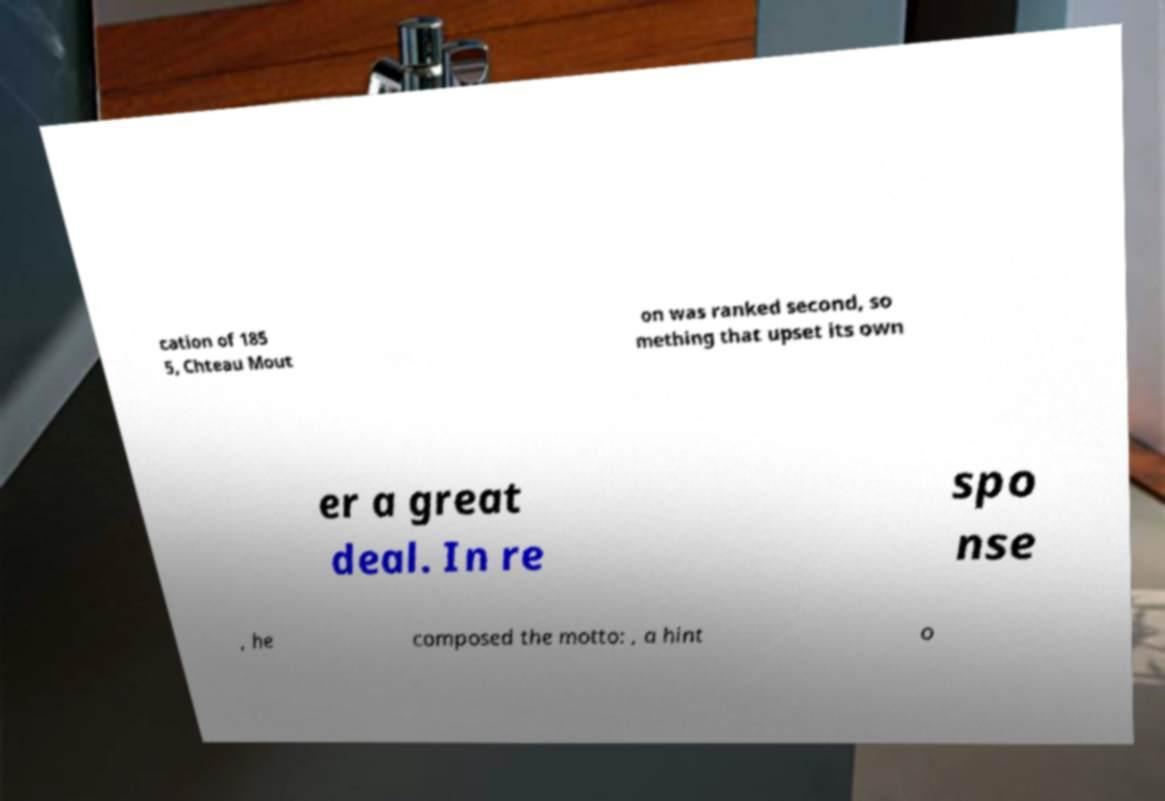I need the written content from this picture converted into text. Can you do that? cation of 185 5, Chteau Mout on was ranked second, so mething that upset its own er a great deal. In re spo nse , he composed the motto: , a hint o 